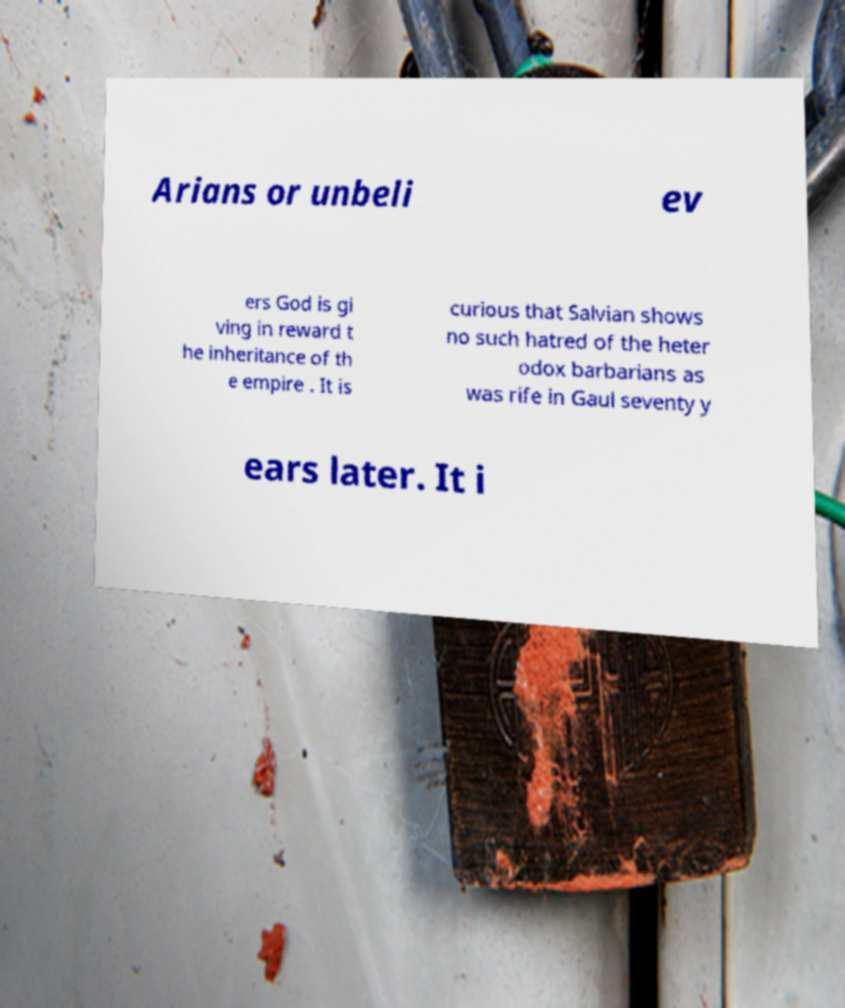What messages or text are displayed in this image? I need them in a readable, typed format. Arians or unbeli ev ers God is gi ving in reward t he inheritance of th e empire . It is curious that Salvian shows no such hatred of the heter odox barbarians as was rife in Gaul seventy y ears later. It i 